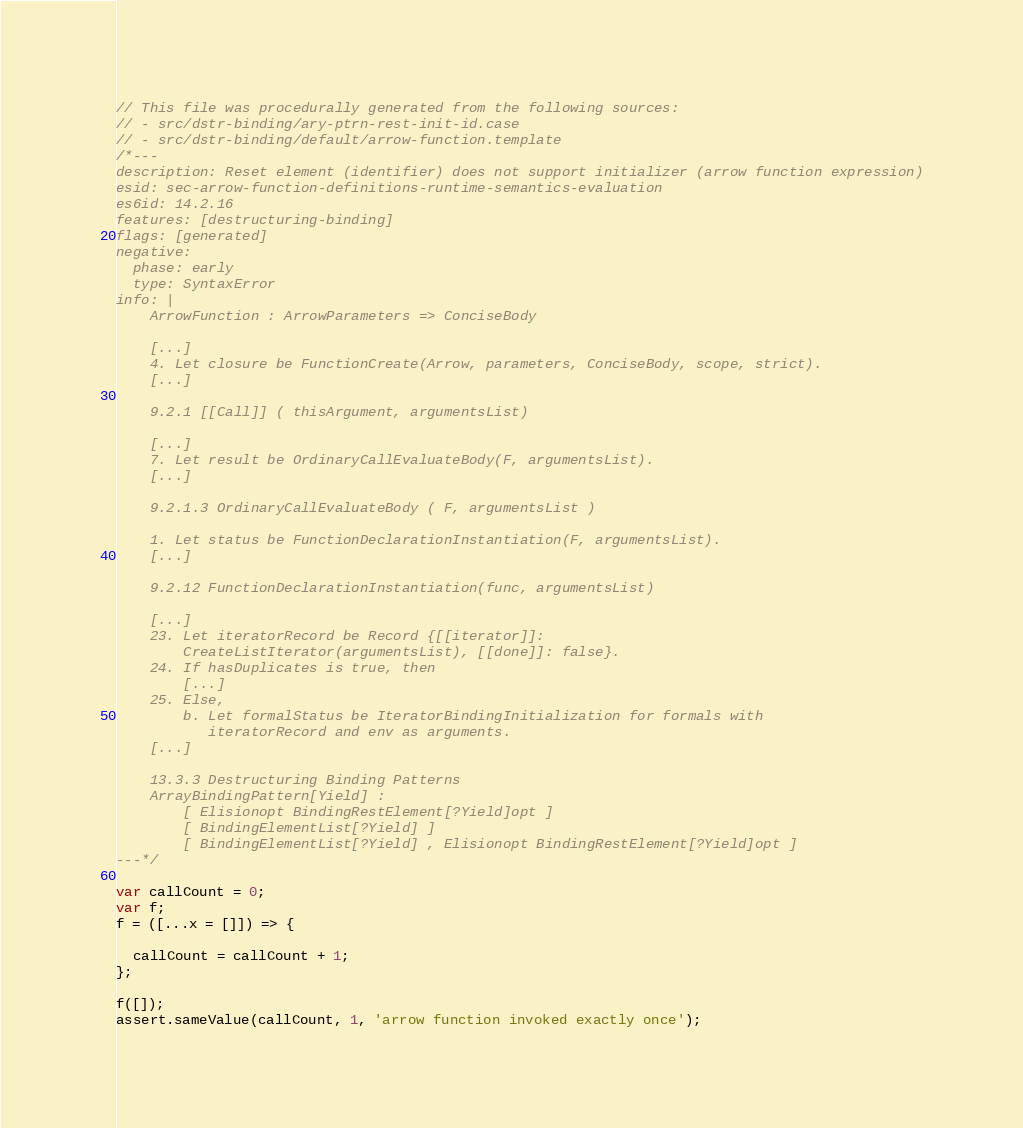Convert code to text. <code><loc_0><loc_0><loc_500><loc_500><_JavaScript_>// This file was procedurally generated from the following sources:
// - src/dstr-binding/ary-ptrn-rest-init-id.case
// - src/dstr-binding/default/arrow-function.template
/*---
description: Reset element (identifier) does not support initializer (arrow function expression)
esid: sec-arrow-function-definitions-runtime-semantics-evaluation
es6id: 14.2.16
features: [destructuring-binding]
flags: [generated]
negative:
  phase: early
  type: SyntaxError
info: |
    ArrowFunction : ArrowParameters => ConciseBody

    [...]
    4. Let closure be FunctionCreate(Arrow, parameters, ConciseBody, scope, strict).
    [...]

    9.2.1 [[Call]] ( thisArgument, argumentsList)

    [...]
    7. Let result be OrdinaryCallEvaluateBody(F, argumentsList).
    [...]

    9.2.1.3 OrdinaryCallEvaluateBody ( F, argumentsList )

    1. Let status be FunctionDeclarationInstantiation(F, argumentsList).
    [...]

    9.2.12 FunctionDeclarationInstantiation(func, argumentsList)

    [...]
    23. Let iteratorRecord be Record {[[iterator]]:
        CreateListIterator(argumentsList), [[done]]: false}.
    24. If hasDuplicates is true, then
        [...]
    25. Else,
        b. Let formalStatus be IteratorBindingInitialization for formals with
           iteratorRecord and env as arguments.
    [...]

    13.3.3 Destructuring Binding Patterns
    ArrayBindingPattern[Yield] :
        [ Elisionopt BindingRestElement[?Yield]opt ]
        [ BindingElementList[?Yield] ]
        [ BindingElementList[?Yield] , Elisionopt BindingRestElement[?Yield]opt ]
---*/

var callCount = 0;
var f;
f = ([...x = []]) => {
  
  callCount = callCount + 1;
};

f([]);
assert.sameValue(callCount, 1, 'arrow function invoked exactly once');
</code> 